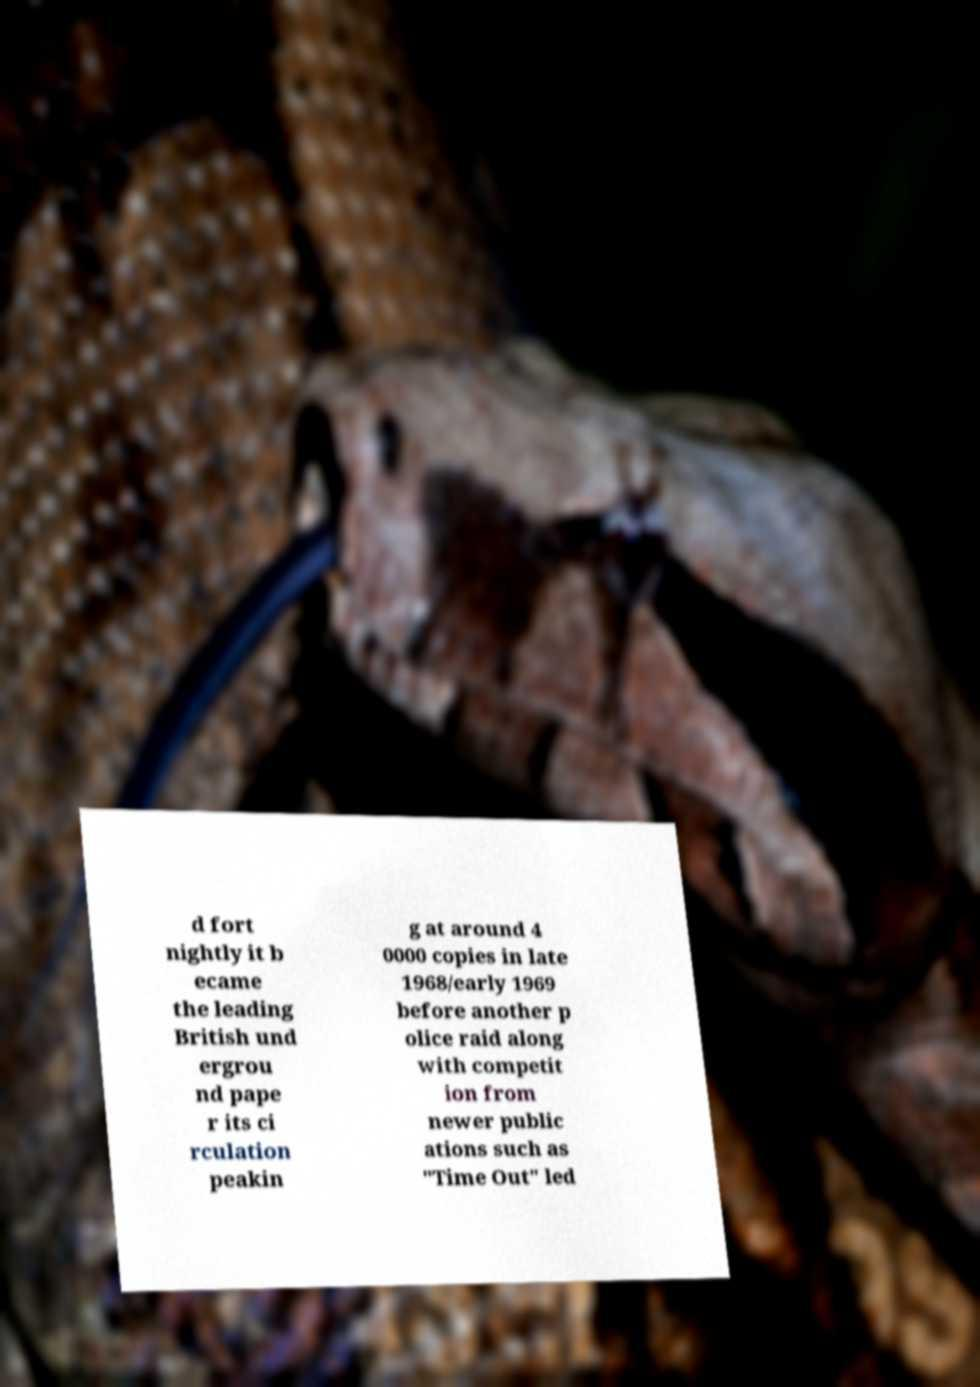Can you accurately transcribe the text from the provided image for me? d fort nightly it b ecame the leading British und ergrou nd pape r its ci rculation peakin g at around 4 0000 copies in late 1968/early 1969 before another p olice raid along with competit ion from newer public ations such as "Time Out" led 